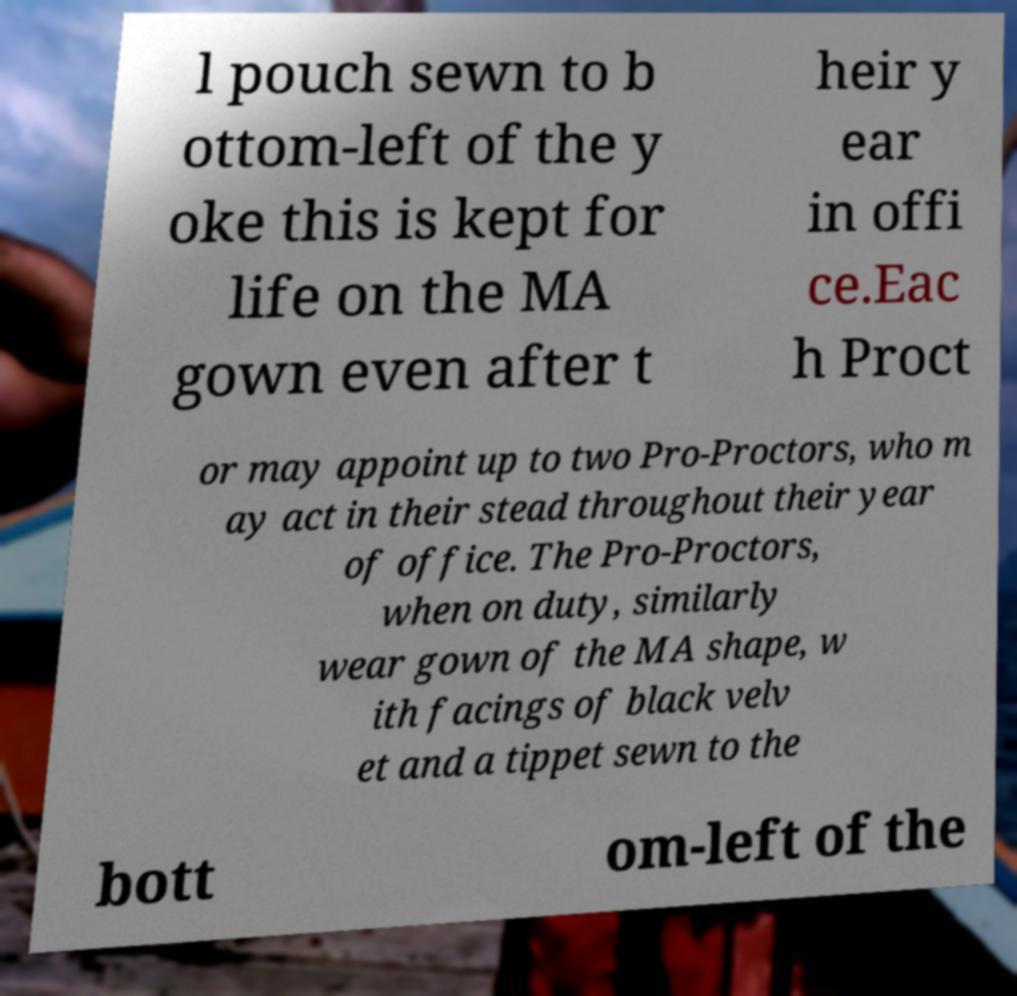Could you assist in decoding the text presented in this image and type it out clearly? l pouch sewn to b ottom-left of the y oke this is kept for life on the MA gown even after t heir y ear in offi ce.Eac h Proct or may appoint up to two Pro-Proctors, who m ay act in their stead throughout their year of office. The Pro-Proctors, when on duty, similarly wear gown of the MA shape, w ith facings of black velv et and a tippet sewn to the bott om-left of the 